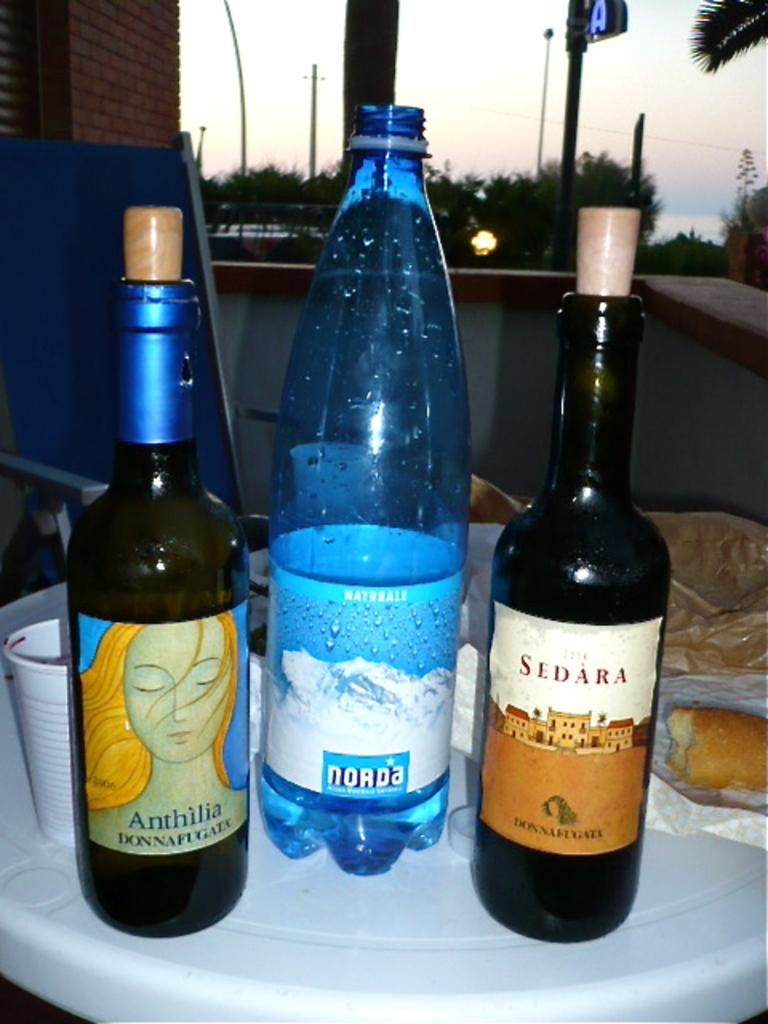What is the main piece of furniture in the image? There is a table in the image. What items are on the table? There is a wine bottle, a glass, and a water bottle on the table. What can be seen in the background of the image? There is a sky, trees, and wall bricks visible in the background of the image. What type of competition is taking place in the image? There is no competition present in the image. Can you tell me where the monkey is hiding in the image? There is no monkey present in the image. 